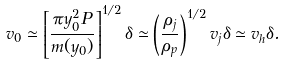Convert formula to latex. <formula><loc_0><loc_0><loc_500><loc_500>v _ { 0 } \simeq \left [ \frac { \pi y _ { 0 } ^ { 2 } P } { m ( y _ { 0 } ) } \right ] ^ { 1 / 2 } \delta \simeq \left ( \frac { \rho _ { j } } { \rho _ { p } } \right ) ^ { 1 / 2 } v _ { j } \delta \simeq v _ { h } \delta .</formula> 